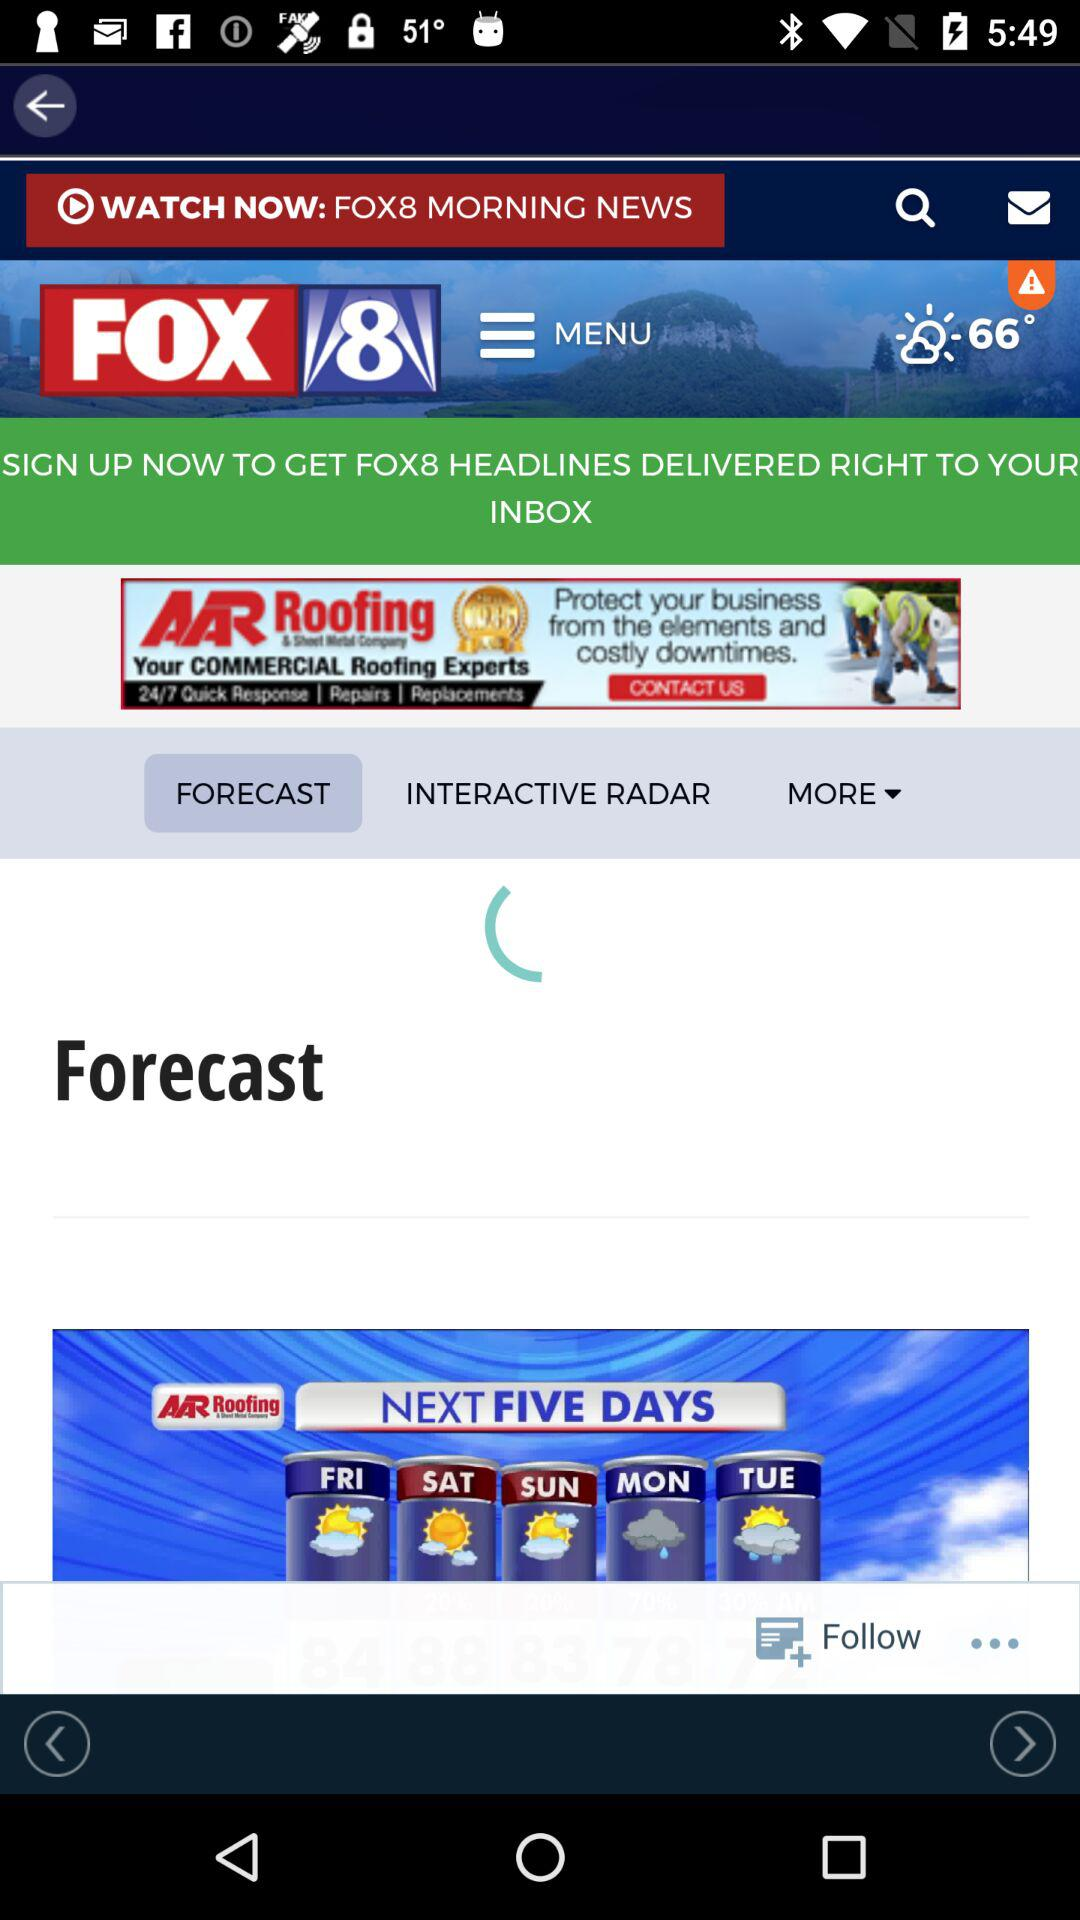What is the temperature today? The temperature is 66°. 